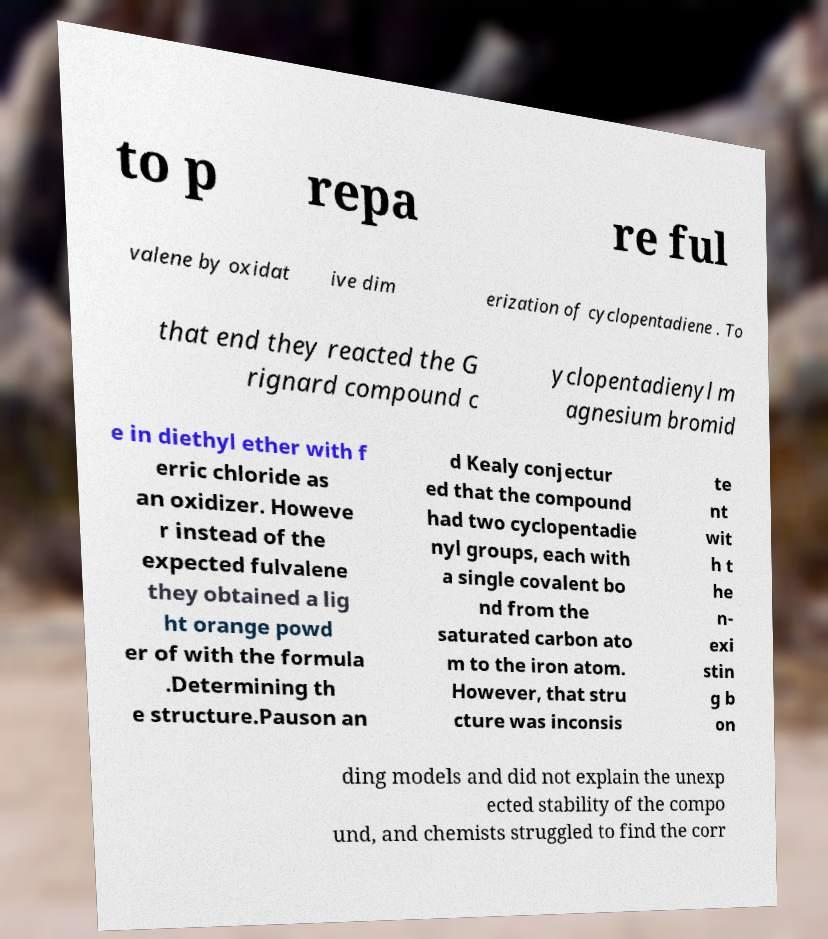Can you read and provide the text displayed in the image?This photo seems to have some interesting text. Can you extract and type it out for me? to p repa re ful valene by oxidat ive dim erization of cyclopentadiene . To that end they reacted the G rignard compound c yclopentadienyl m agnesium bromid e in diethyl ether with f erric chloride as an oxidizer. Howeve r instead of the expected fulvalene they obtained a lig ht orange powd er of with the formula .Determining th e structure.Pauson an d Kealy conjectur ed that the compound had two cyclopentadie nyl groups, each with a single covalent bo nd from the saturated carbon ato m to the iron atom. However, that stru cture was inconsis te nt wit h t he n- exi stin g b on ding models and did not explain the unexp ected stability of the compo und, and chemists struggled to find the corr 